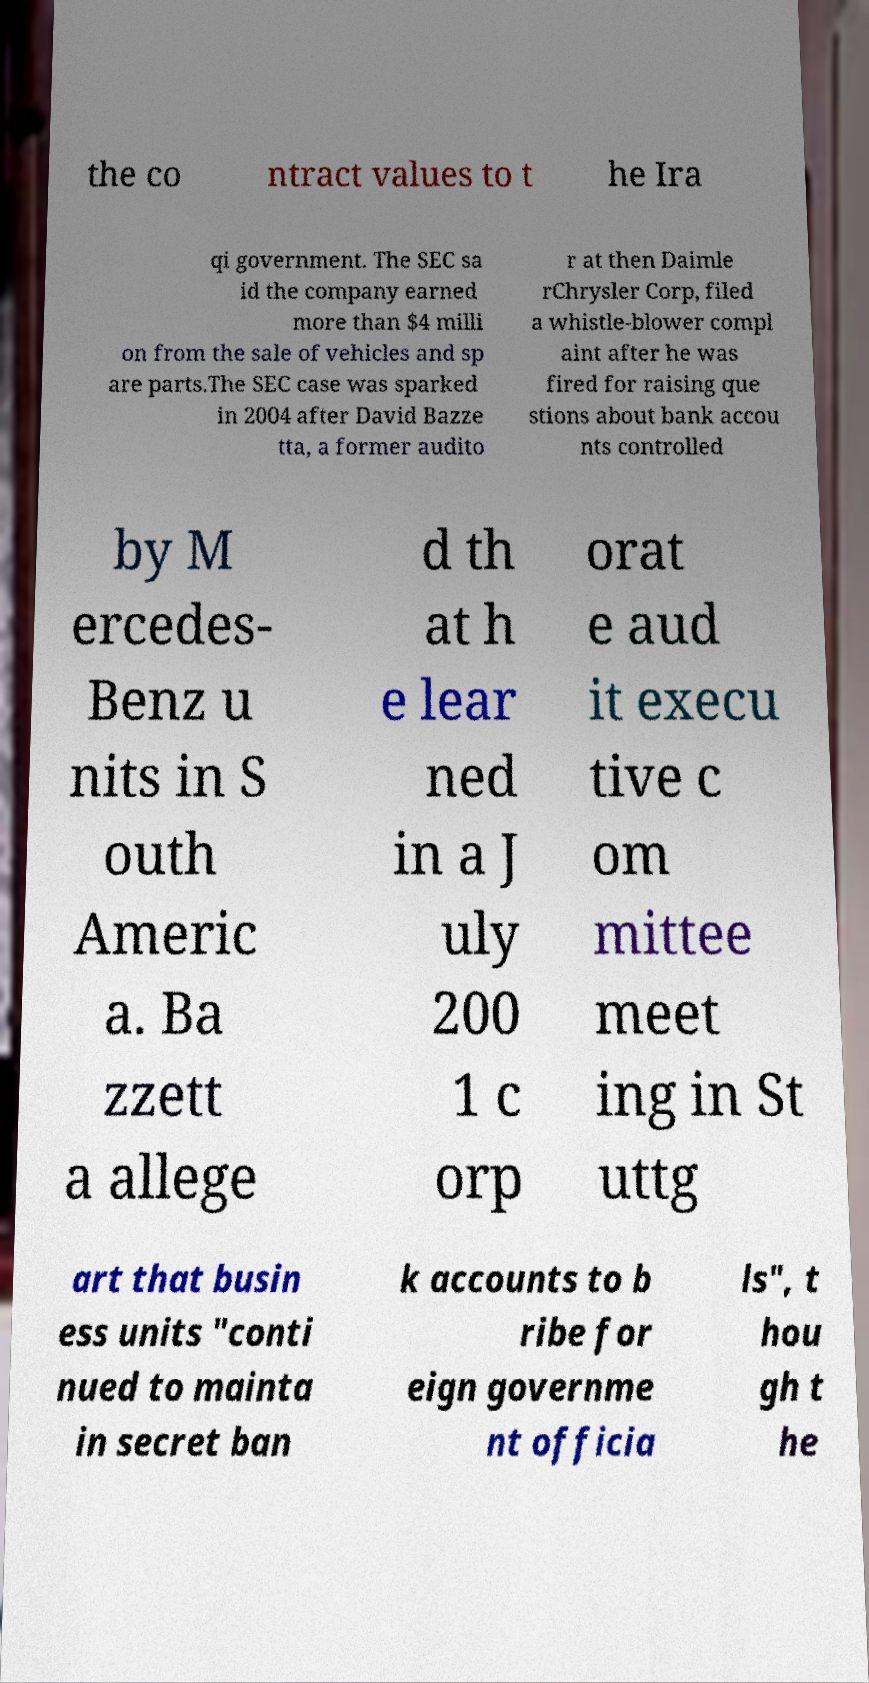Please identify and transcribe the text found in this image. the co ntract values to t he Ira qi government. The SEC sa id the company earned more than $4 milli on from the sale of vehicles and sp are parts.The SEC case was sparked in 2004 after David Bazze tta, a former audito r at then Daimle rChrysler Corp, filed a whistle-blower compl aint after he was fired for raising que stions about bank accou nts controlled by M ercedes- Benz u nits in S outh Americ a. Ba zzett a allege d th at h e lear ned in a J uly 200 1 c orp orat e aud it execu tive c om mittee meet ing in St uttg art that busin ess units "conti nued to mainta in secret ban k accounts to b ribe for eign governme nt officia ls", t hou gh t he 